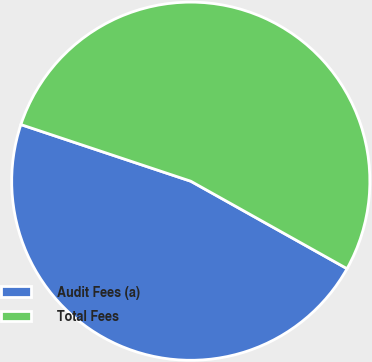<chart> <loc_0><loc_0><loc_500><loc_500><pie_chart><fcel>Audit Fees (a)<fcel>Total Fees<nl><fcel>47.0%<fcel>53.0%<nl></chart> 